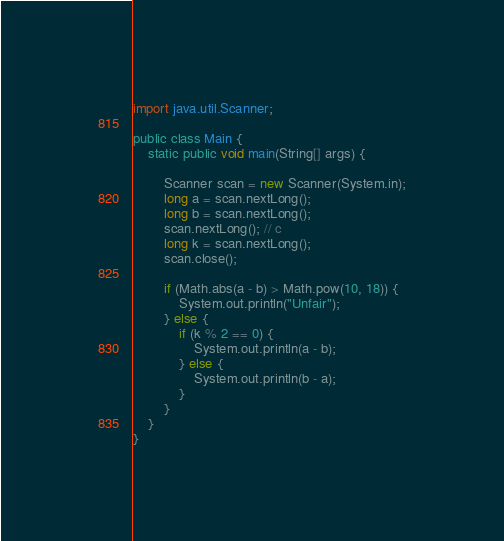<code> <loc_0><loc_0><loc_500><loc_500><_Java_>import java.util.Scanner;

public class Main {
	static public void main(String[] args) {

		Scanner scan = new Scanner(System.in);
		long a = scan.nextLong();
		long b = scan.nextLong();
		scan.nextLong(); // c
		long k = scan.nextLong();
		scan.close();

		if (Math.abs(a - b) > Math.pow(10, 18)) {
			System.out.println("Unfair");
		} else {
			if (k % 2 == 0) {
				System.out.println(a - b);
			} else {
				System.out.println(b - a);
			}
		}
	}
}
</code> 